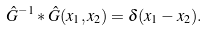Convert formula to latex. <formula><loc_0><loc_0><loc_500><loc_500>\hat { G } ^ { - 1 } \ast \hat { G } ( x _ { 1 } , x _ { 2 } ) = \delta ( x _ { 1 } - x _ { 2 } ) .</formula> 